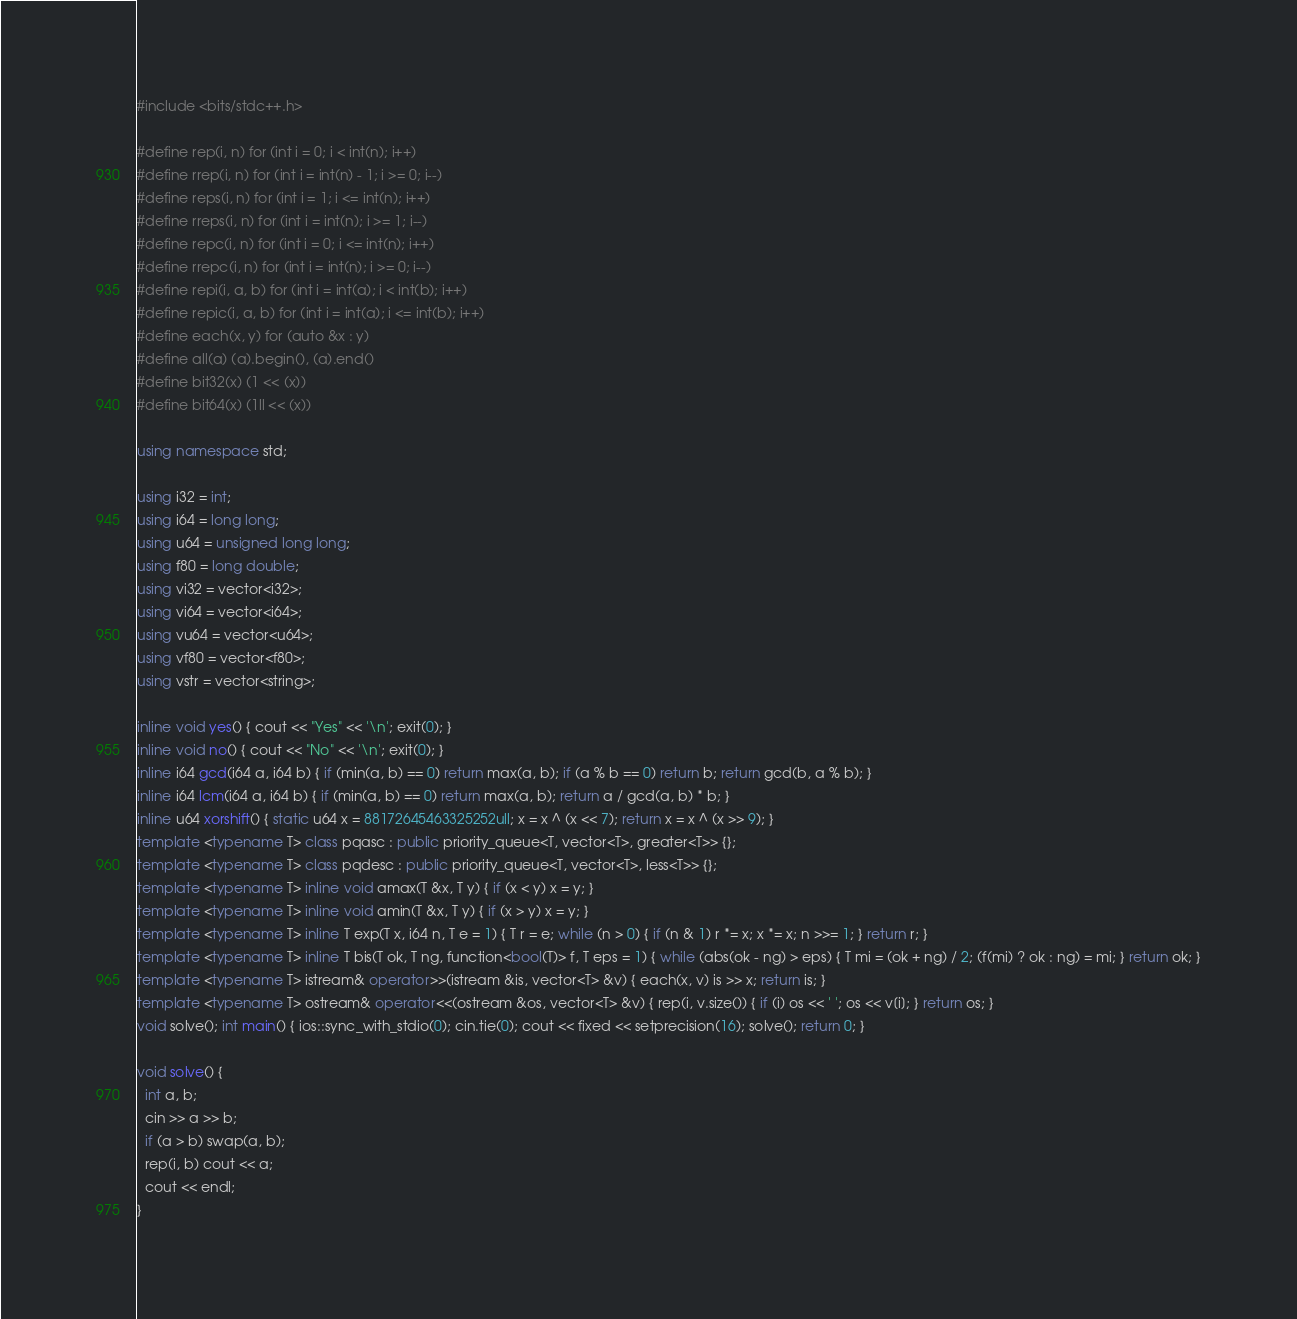Convert code to text. <code><loc_0><loc_0><loc_500><loc_500><_C++_>#include <bits/stdc++.h>

#define rep(i, n) for (int i = 0; i < int(n); i++)
#define rrep(i, n) for (int i = int(n) - 1; i >= 0; i--)
#define reps(i, n) for (int i = 1; i <= int(n); i++)
#define rreps(i, n) for (int i = int(n); i >= 1; i--)
#define repc(i, n) for (int i = 0; i <= int(n); i++)
#define rrepc(i, n) for (int i = int(n); i >= 0; i--)
#define repi(i, a, b) for (int i = int(a); i < int(b); i++)
#define repic(i, a, b) for (int i = int(a); i <= int(b); i++)
#define each(x, y) for (auto &x : y)
#define all(a) (a).begin(), (a).end()
#define bit32(x) (1 << (x))
#define bit64(x) (1ll << (x))

using namespace std;

using i32 = int;
using i64 = long long;
using u64 = unsigned long long;
using f80 = long double;
using vi32 = vector<i32>;
using vi64 = vector<i64>;
using vu64 = vector<u64>;
using vf80 = vector<f80>;
using vstr = vector<string>;

inline void yes() { cout << "Yes" << '\n'; exit(0); }
inline void no() { cout << "No" << '\n'; exit(0); }
inline i64 gcd(i64 a, i64 b) { if (min(a, b) == 0) return max(a, b); if (a % b == 0) return b; return gcd(b, a % b); }
inline i64 lcm(i64 a, i64 b) { if (min(a, b) == 0) return max(a, b); return a / gcd(a, b) * b; }
inline u64 xorshift() { static u64 x = 88172645463325252ull; x = x ^ (x << 7); return x = x ^ (x >> 9); }
template <typename T> class pqasc : public priority_queue<T, vector<T>, greater<T>> {};
template <typename T> class pqdesc : public priority_queue<T, vector<T>, less<T>> {};
template <typename T> inline void amax(T &x, T y) { if (x < y) x = y; }
template <typename T> inline void amin(T &x, T y) { if (x > y) x = y; }
template <typename T> inline T exp(T x, i64 n, T e = 1) { T r = e; while (n > 0) { if (n & 1) r *= x; x *= x; n >>= 1; } return r; }
template <typename T> inline T bis(T ok, T ng, function<bool(T)> f, T eps = 1) { while (abs(ok - ng) > eps) { T mi = (ok + ng) / 2; (f(mi) ? ok : ng) = mi; } return ok; }
template <typename T> istream& operator>>(istream &is, vector<T> &v) { each(x, v) is >> x; return is; }
template <typename T> ostream& operator<<(ostream &os, vector<T> &v) { rep(i, v.size()) { if (i) os << ' '; os << v[i]; } return os; }
void solve(); int main() { ios::sync_with_stdio(0); cin.tie(0); cout << fixed << setprecision(16); solve(); return 0; }

void solve() {
  int a, b;
  cin >> a >> b;
  if (a > b) swap(a, b);
  rep(i, b) cout << a;
  cout << endl;
}
</code> 